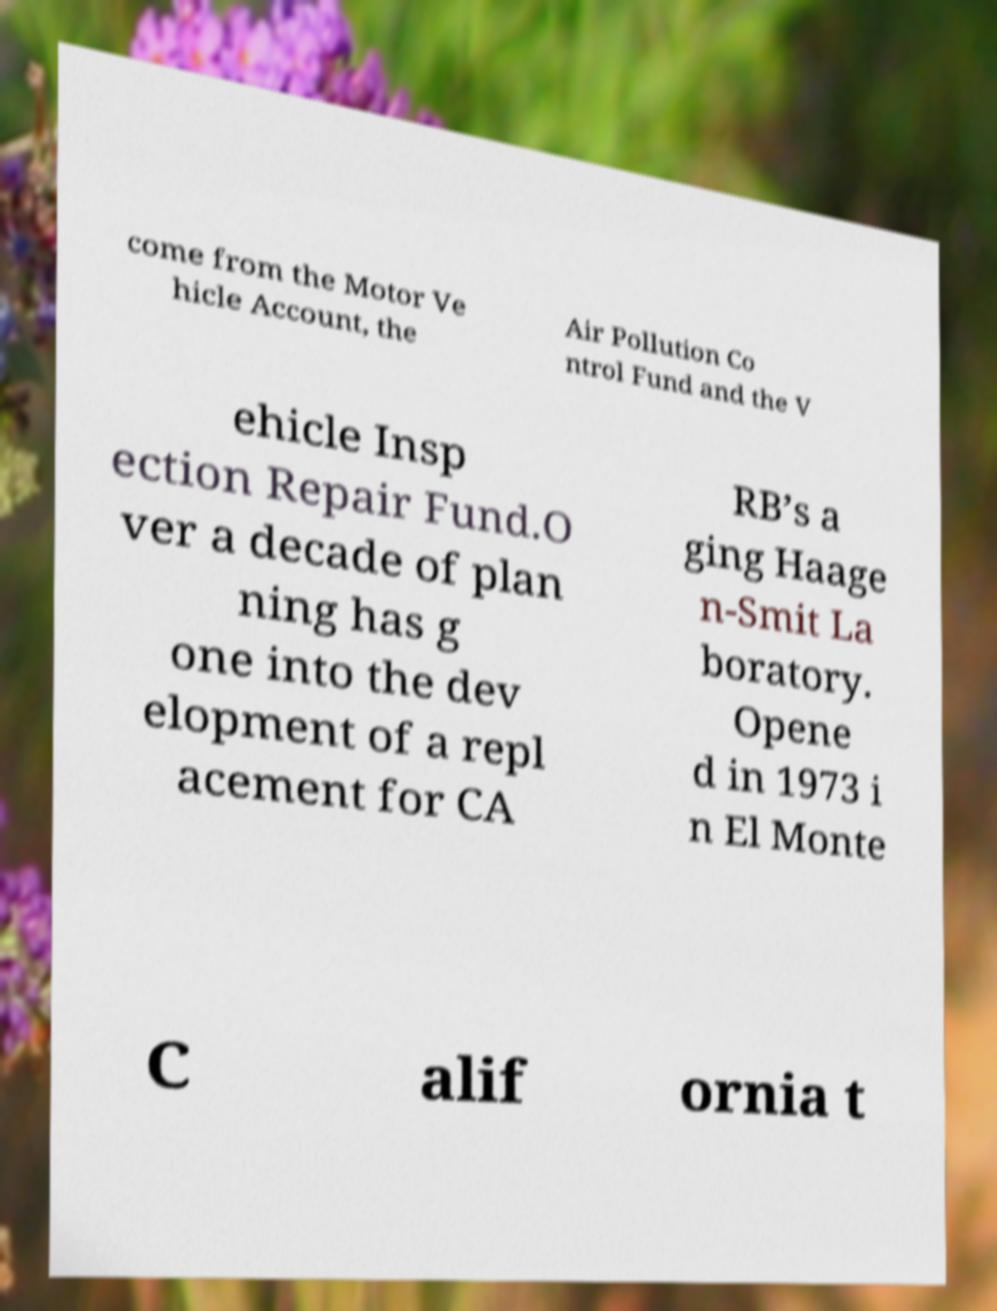What messages or text are displayed in this image? I need them in a readable, typed format. come from the Motor Ve hicle Account, the Air Pollution Co ntrol Fund and the V ehicle Insp ection Repair Fund.O ver a decade of plan ning has g one into the dev elopment of a repl acement for CA RB’s a ging Haage n-Smit La boratory. Opene d in 1973 i n El Monte C alif ornia t 